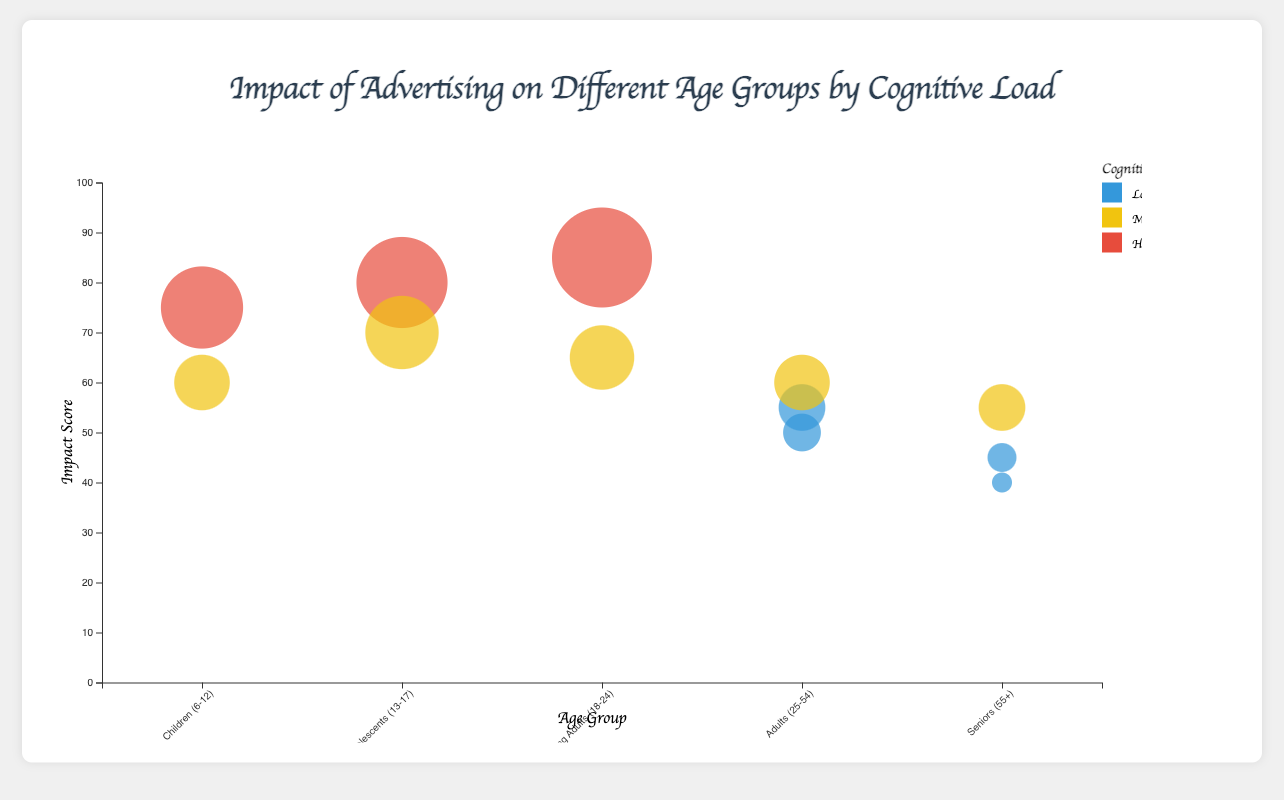What is the highest impact score in the chart? Look for the bubble that has the highest vertical position. It is at a score of 85 for "Young Adults (18-24)" under "Social Media" advertisement type with "High" cognitive load.
Answer: 85 Which age group has the lowest impact score and what is that score? Identify the lowest bubble on the y-axis, which is at a score of 40 for "Seniors (55+)" under "Print Media" with "Low" cognitive load.
Answer: Seniors (55+), 40 How does the impact score for "Online" advertisements compare between "Children (6-12)" and "Seniors (55+)"? Locate the bubbles for "Online" advertisement type for both age groups. "Children (6-12)" have a score of 60 while "Seniors (55+)" have a score of 55.
Answer: Children (6-12) have a higher score, 60 vs. 55 What is the average impact score for the "Television" advertisement type across all age groups? Find the impact scores for "Television" advertisements for all age groups: 75 (Children), 80 (Adolescents), 65 (Young Adults), 55 (Adults), and 45 (Seniors). Calculate the average: (75+80+65+55+45)/5 = 64
Answer: 64 Which cognitive load category has the most number of data points represented in the chart? Count the number of bubbles for each cognitive load category: Low, Medium, and High. "Low" has 5, "Medium" has 4, and "High" has 3.
Answer: Low Is there any age group that has "High" cognitive load but an impact score below 70? Check all bubbles with "High" cognitive load. None of them have an impact score below 70.
Answer: No Are there any advertisement types that are present in all age groups? Check the advertisement types for each age group. Only "Television" and "Online" appear in the majority of age groups. Drilling down, "Television" is present in all age groups.
Answer: Television What is the total number of data points represented in the chart? Count all bubbles in the chart; there are 12 data points in total.
Answer: 12 